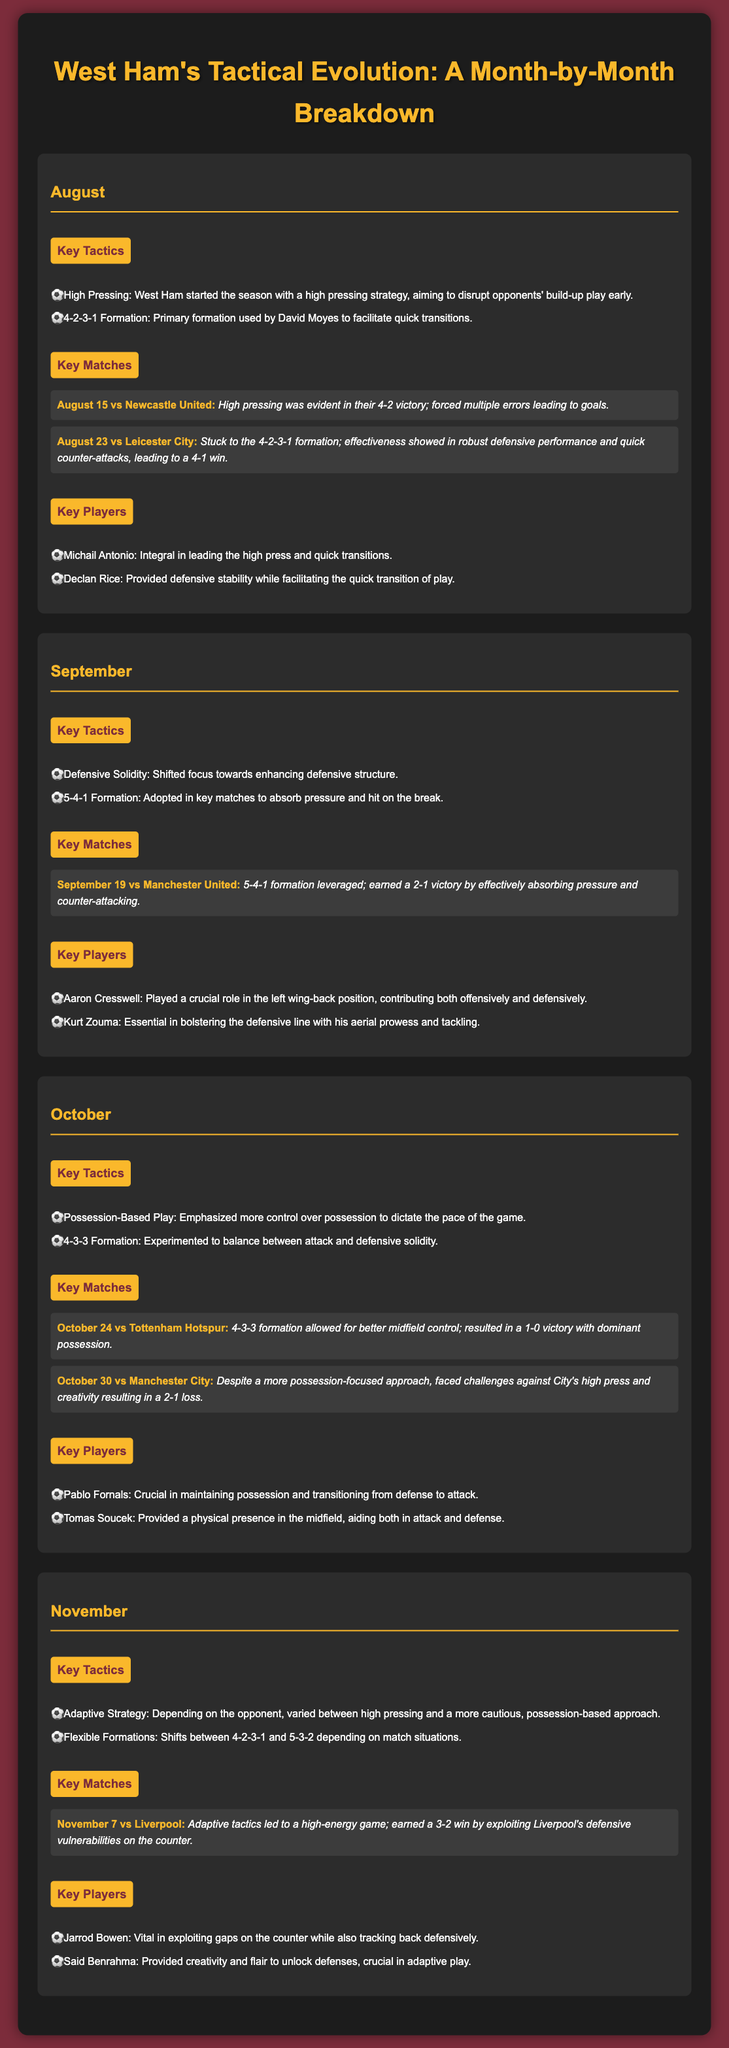What are the key tactics in August? The key tactics in August include high pressing and 4-2-3-1 formation.
Answer: High Pressing, 4-2-3-1 Formation Which formation did West Ham use against Manchester United in September? The formation used against Manchester United in September was 5-4-1.
Answer: 5-4-1 What was the result of the match against Tottenham Hotspur in October? The result of the match against Tottenham Hotspur in October was a 1-0 victory.
Answer: 1-0 victory Who were the key players in November? The key players in November were Jarrod Bowen and Said Benrahma.
Answer: Jarrod Bowen, Said Benrahma How many key matches are mentioned for September? The document mentions one key match for September.
Answer: One What tactical shift occurred in October? The tactical shift in October was towards possession-based play.
Answer: Possession-Based Play Which match did West Ham win in November? West Ham won the match against Liverpool in November.
Answer: Liverpool What is the primary formation discussed for August? The primary formation discussed for August is 4-2-3-1.
Answer: 4-2-3-1 